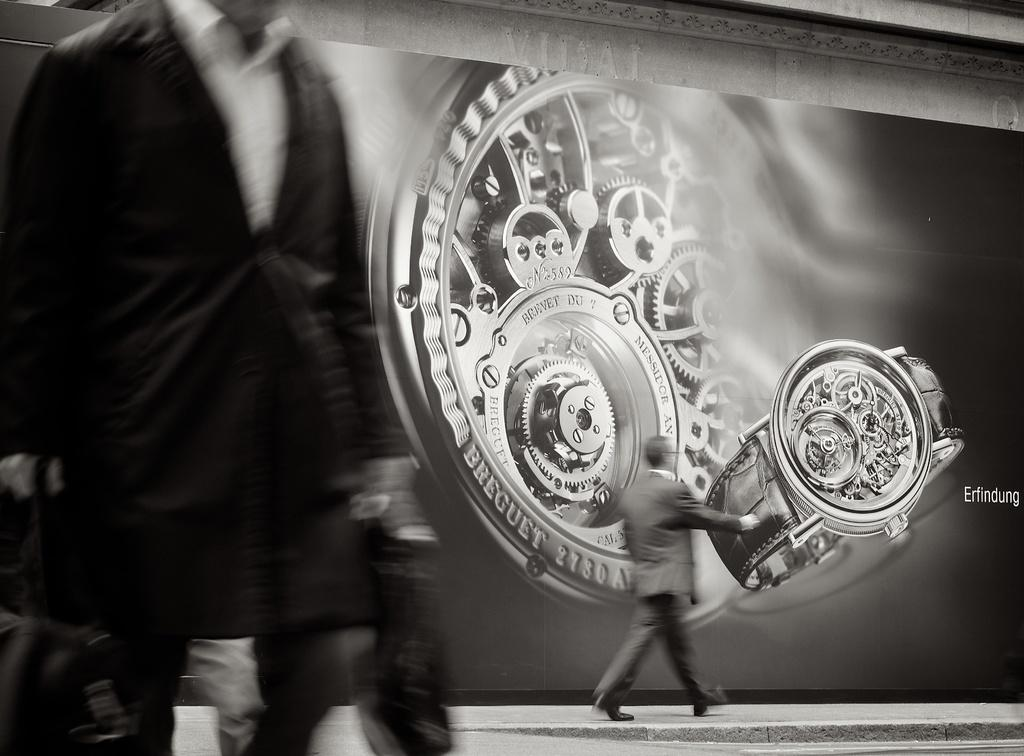<image>
Share a concise interpretation of the image provided. A watch advertisement in black and white from the company Breguet 